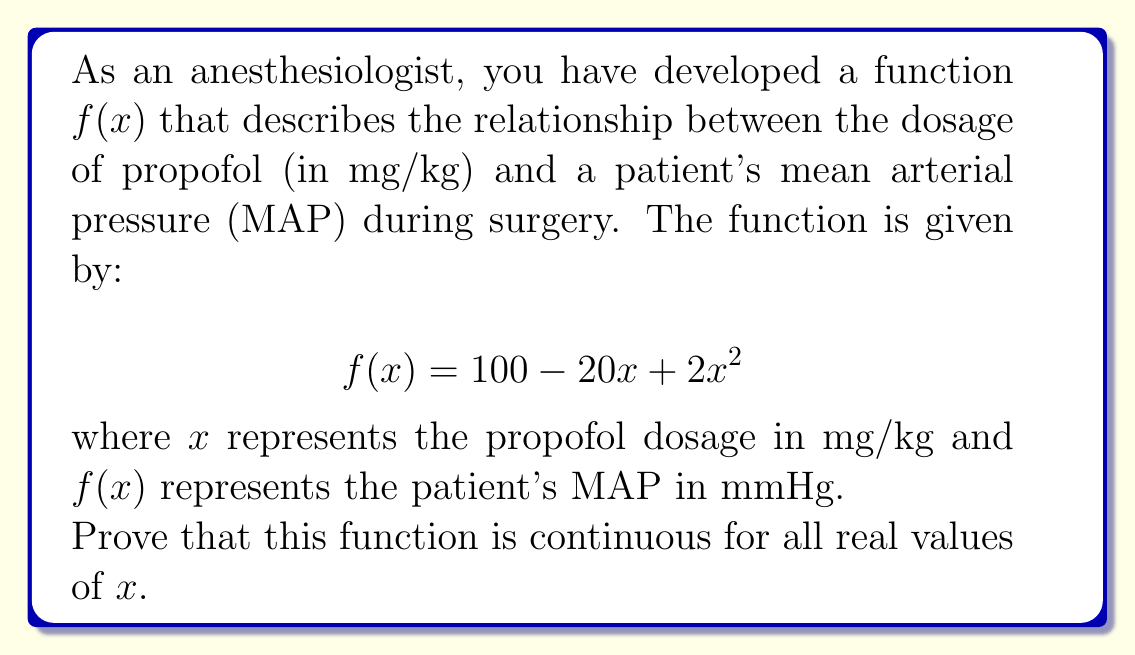Could you help me with this problem? To prove that the function $f(x) = 100 - 20x + 2x^2$ is continuous for all real values of $x$, we need to show that it satisfies the definition of continuity. A function is continuous at a point if it satisfies three conditions:

1. The function is defined at that point.
2. The limit of the function exists as we approach that point.
3. The limit equals the function value at that point.

Let's prove this for an arbitrary point $a$:

Step 1: Show that $f(x)$ is defined for all real $x$.
$f(x) = 100 - 20x + 2x^2$ is a polynomial function, which is defined for all real numbers. Thus, it is defined at any arbitrary point $a$.

Step 2: Show that the limit exists as $x$ approaches $a$.
For polynomial functions, the limit always exists and can be evaluated by direct substitution:

$$\lim_{x \to a} f(x) = \lim_{x \to a} (100 - 20x + 2x^2)$$
$$= 100 - 20a + 2a^2$$

Step 3: Show that the limit equals the function value at $a$.
Calculate $f(a)$:
$$f(a) = 100 - 20a + 2a^2$$

We can see that $\lim_{x \to a} f(x) = f(a)$ for any real value of $a$.

Since all three conditions are satisfied for any arbitrary real number $a$, we can conclude that $f(x)$ is continuous for all real values of $x$.
Answer: $f(x)$ is continuous for all real $x$ as it's a polynomial function satisfying the continuity definition at every point. 